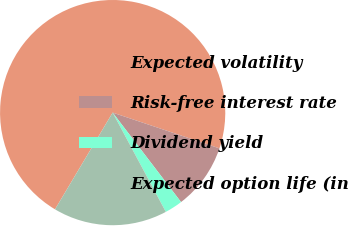Convert chart to OTSL. <chart><loc_0><loc_0><loc_500><loc_500><pie_chart><fcel>Expected volatility<fcel>Risk-free interest rate<fcel>Dividend yield<fcel>Expected option life (in<nl><fcel>71.6%<fcel>9.47%<fcel>2.56%<fcel>16.38%<nl></chart> 